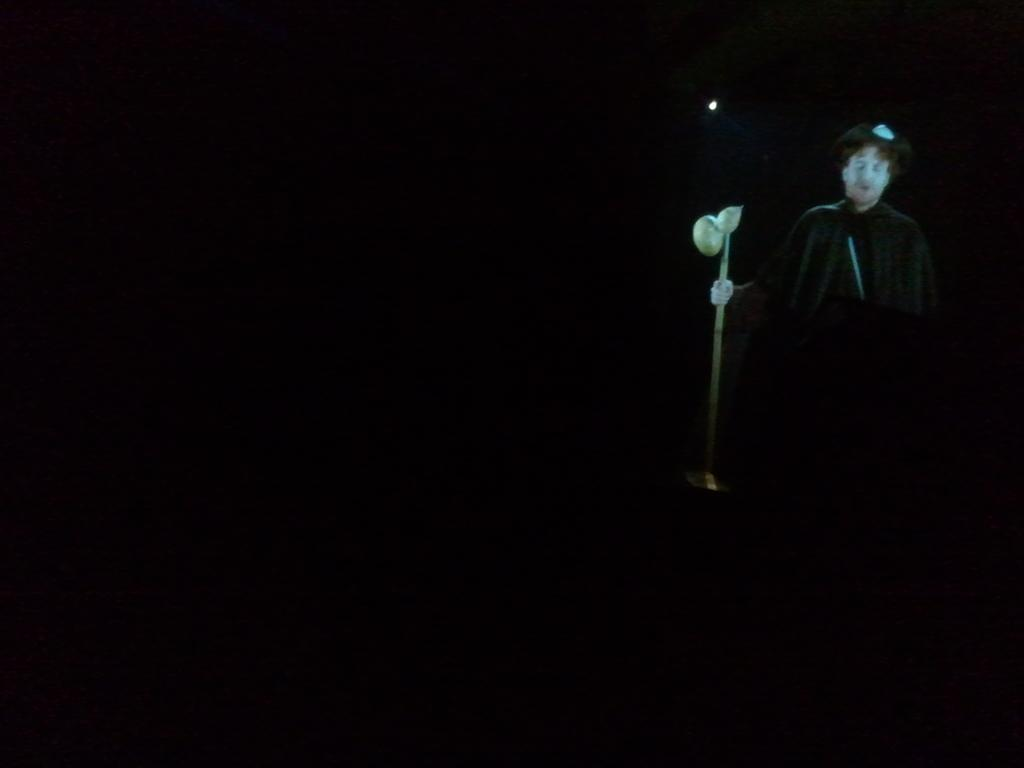What is the main subject of the image? The main subject of the image is a person. What is the person holding in the image? The person is holding a stick. What is the color or lighting condition of the background in the image? The background of the image is dark. How many snails can be seen crawling on the person's arm in the image? There are no snails visible on the person's arm in the image. What type of yoke is the person using to hold the stick? There is no yoke present in the image; the person is simply holding the stick. 